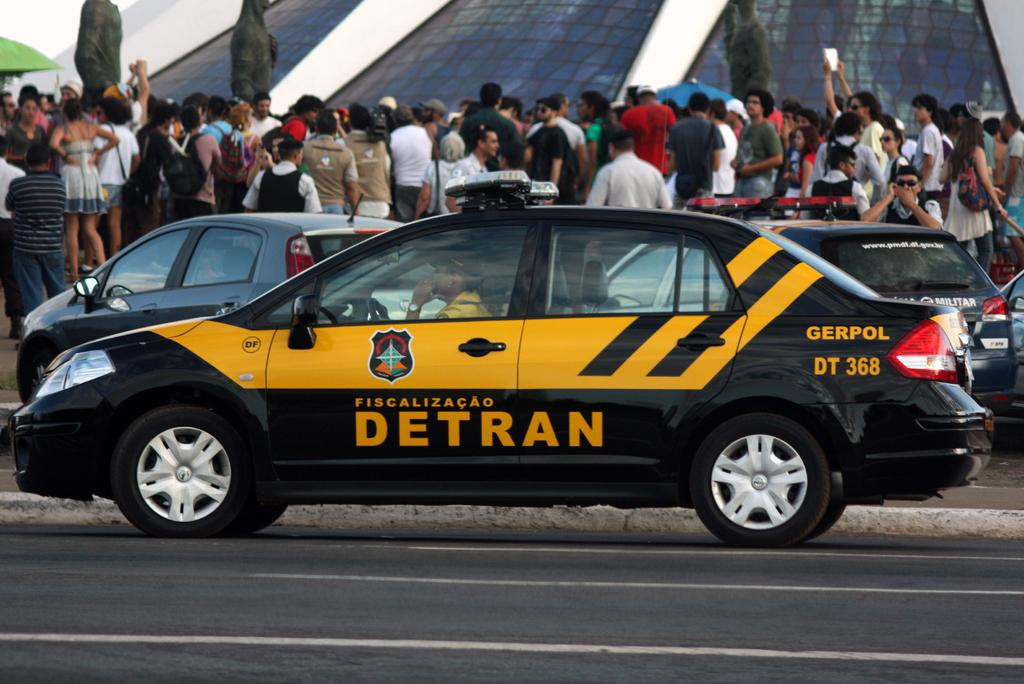<image>
Provide a brief description of the given image. A yellow and black car is on the road with DETRAN GERPOL DT 368 on it. 